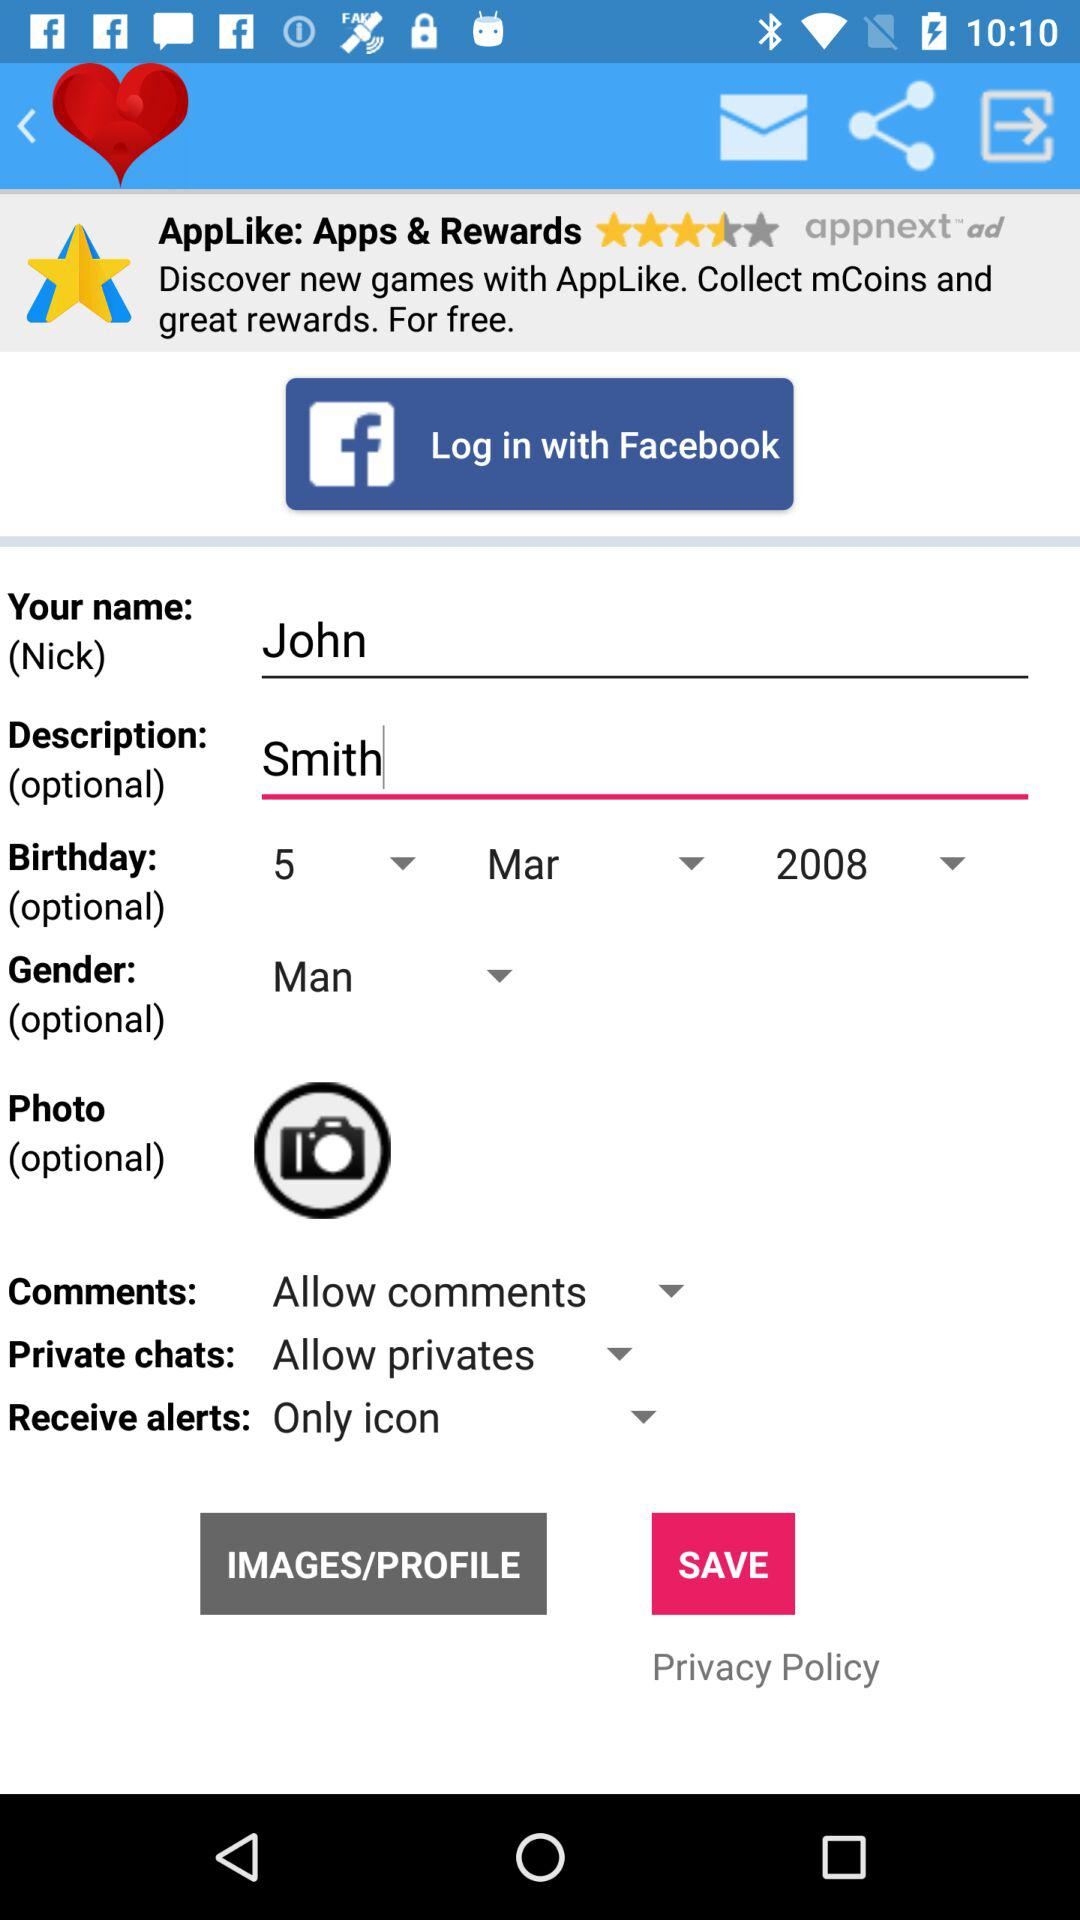What is the selected birthday date? The selected birthday date is March 5, 2008. 